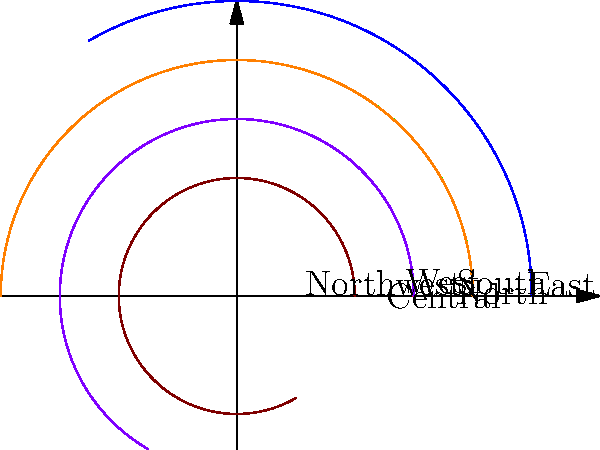The polar graph shows the territorial ranges of dingoes in different regions of the Australian Outback. Each colored segment represents a region, and the length of the segment indicates the relative size of the dingo territory. Which region has the largest dingo territorial range? To determine which region has the largest dingo territorial range, we need to compare the lengths of the colored segments in the polar graph. Each segment represents a different region of the Australian Outback:

1. Central (red)
2. North (green)
3. East (blue)
4. South (orange)
5. West (purple)
6. Northwest (brown)

The length of each segment corresponds to the relative size of the dingo territory in that region. By visually comparing the lengths:

1. Central (red) extends to about 3 units
2. North (green) extends to about 4 units
3. East (blue) extends to about 5 units
4. South (orange) extends to about 4 units
5. West (purple) extends to about 3 units
6. Northwest (brown) extends to about 2 units

The longest segment is the blue one, which represents the East region and extends to about 5 units. This indicates that the East region has the largest dingo territorial range among the given regions.
Answer: East 